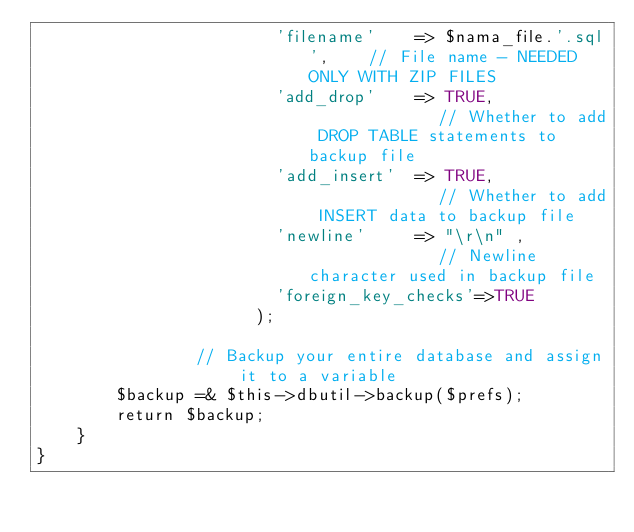<code> <loc_0><loc_0><loc_500><loc_500><_PHP_>                        'filename'    => $nama_file.'.sql',    // File name - NEEDED ONLY WITH ZIP FILES
                        'add_drop'    => TRUE,              // Whether to add DROP TABLE statements to backup file
                        'add_insert'  => TRUE,              // Whether to add INSERT data to backup file
                        'newline'     => "\r\n" ,              // Newline character used in backup file
                        'foreign_key_checks'=>TRUE
                      );

                // Backup your entire database and assign it to a variable
        $backup =& $this->dbutil->backup($prefs);
        return $backup;
	}
}
</code> 